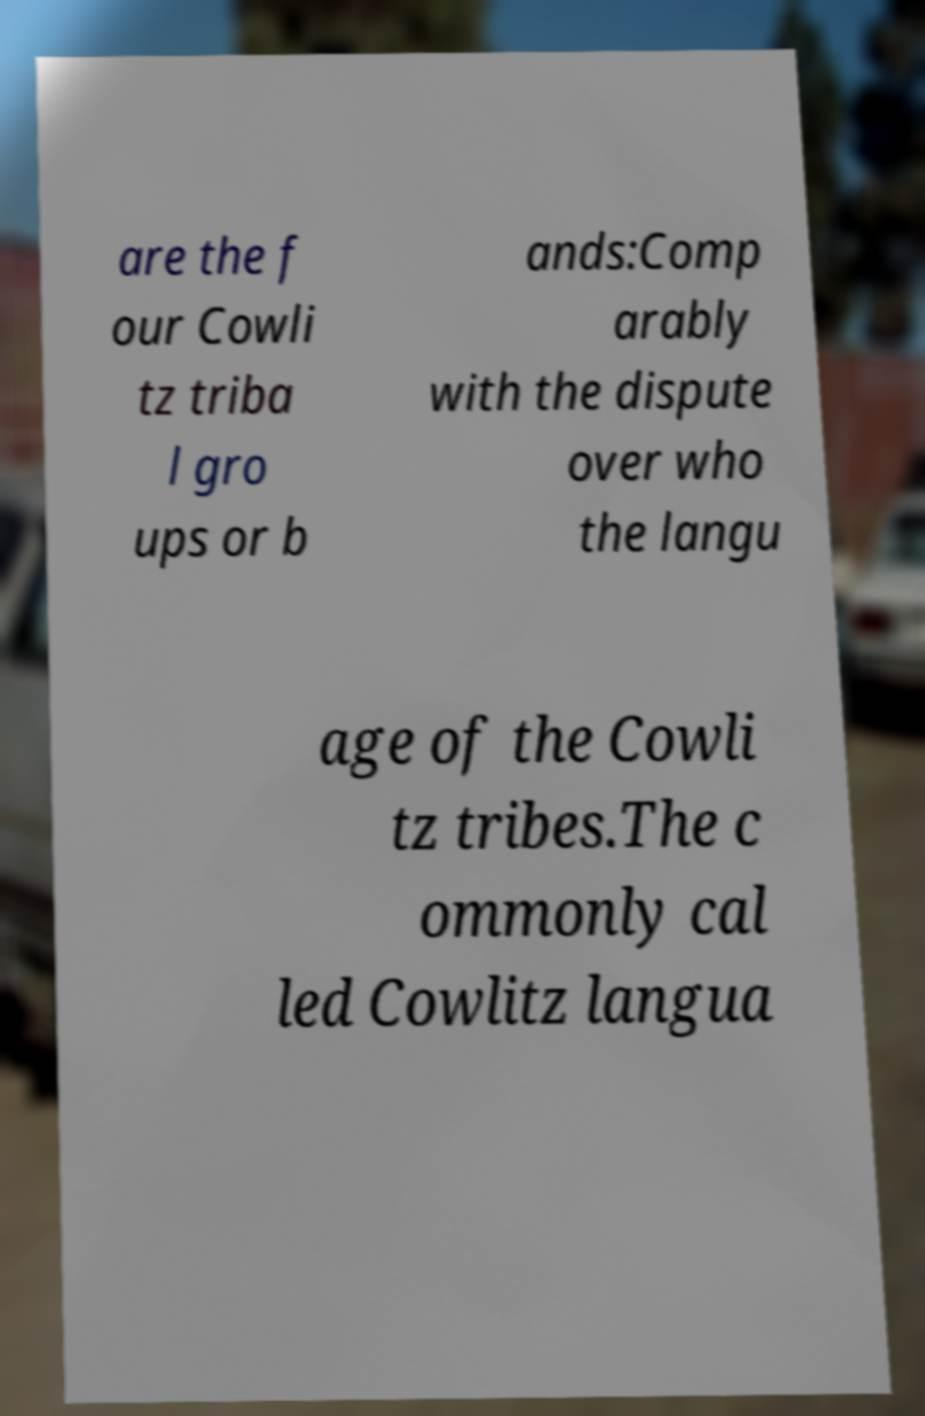Please read and relay the text visible in this image. What does it say? are the f our Cowli tz triba l gro ups or b ands:Comp arably with the dispute over who the langu age of the Cowli tz tribes.The c ommonly cal led Cowlitz langua 